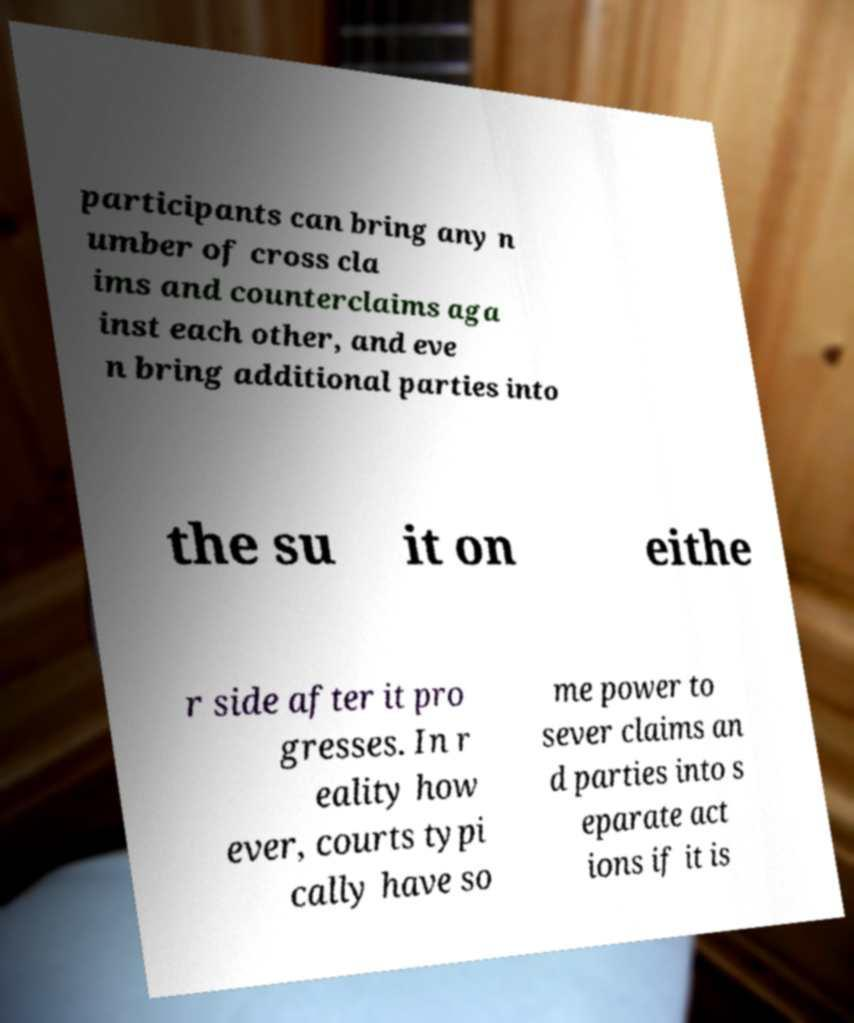I need the written content from this picture converted into text. Can you do that? participants can bring any n umber of cross cla ims and counterclaims aga inst each other, and eve n bring additional parties into the su it on eithe r side after it pro gresses. In r eality how ever, courts typi cally have so me power to sever claims an d parties into s eparate act ions if it is 